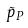<formula> <loc_0><loc_0><loc_500><loc_500>\tilde { p } _ { P }</formula> 